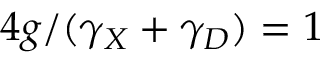<formula> <loc_0><loc_0><loc_500><loc_500>4 g / ( \gamma _ { X } + \gamma _ { D } ) = 1</formula> 